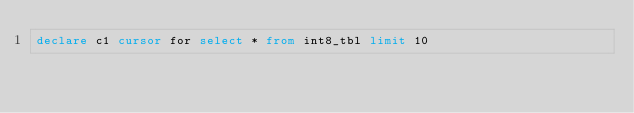<code> <loc_0><loc_0><loc_500><loc_500><_SQL_>declare c1 cursor for select * from int8_tbl limit 10
</code> 